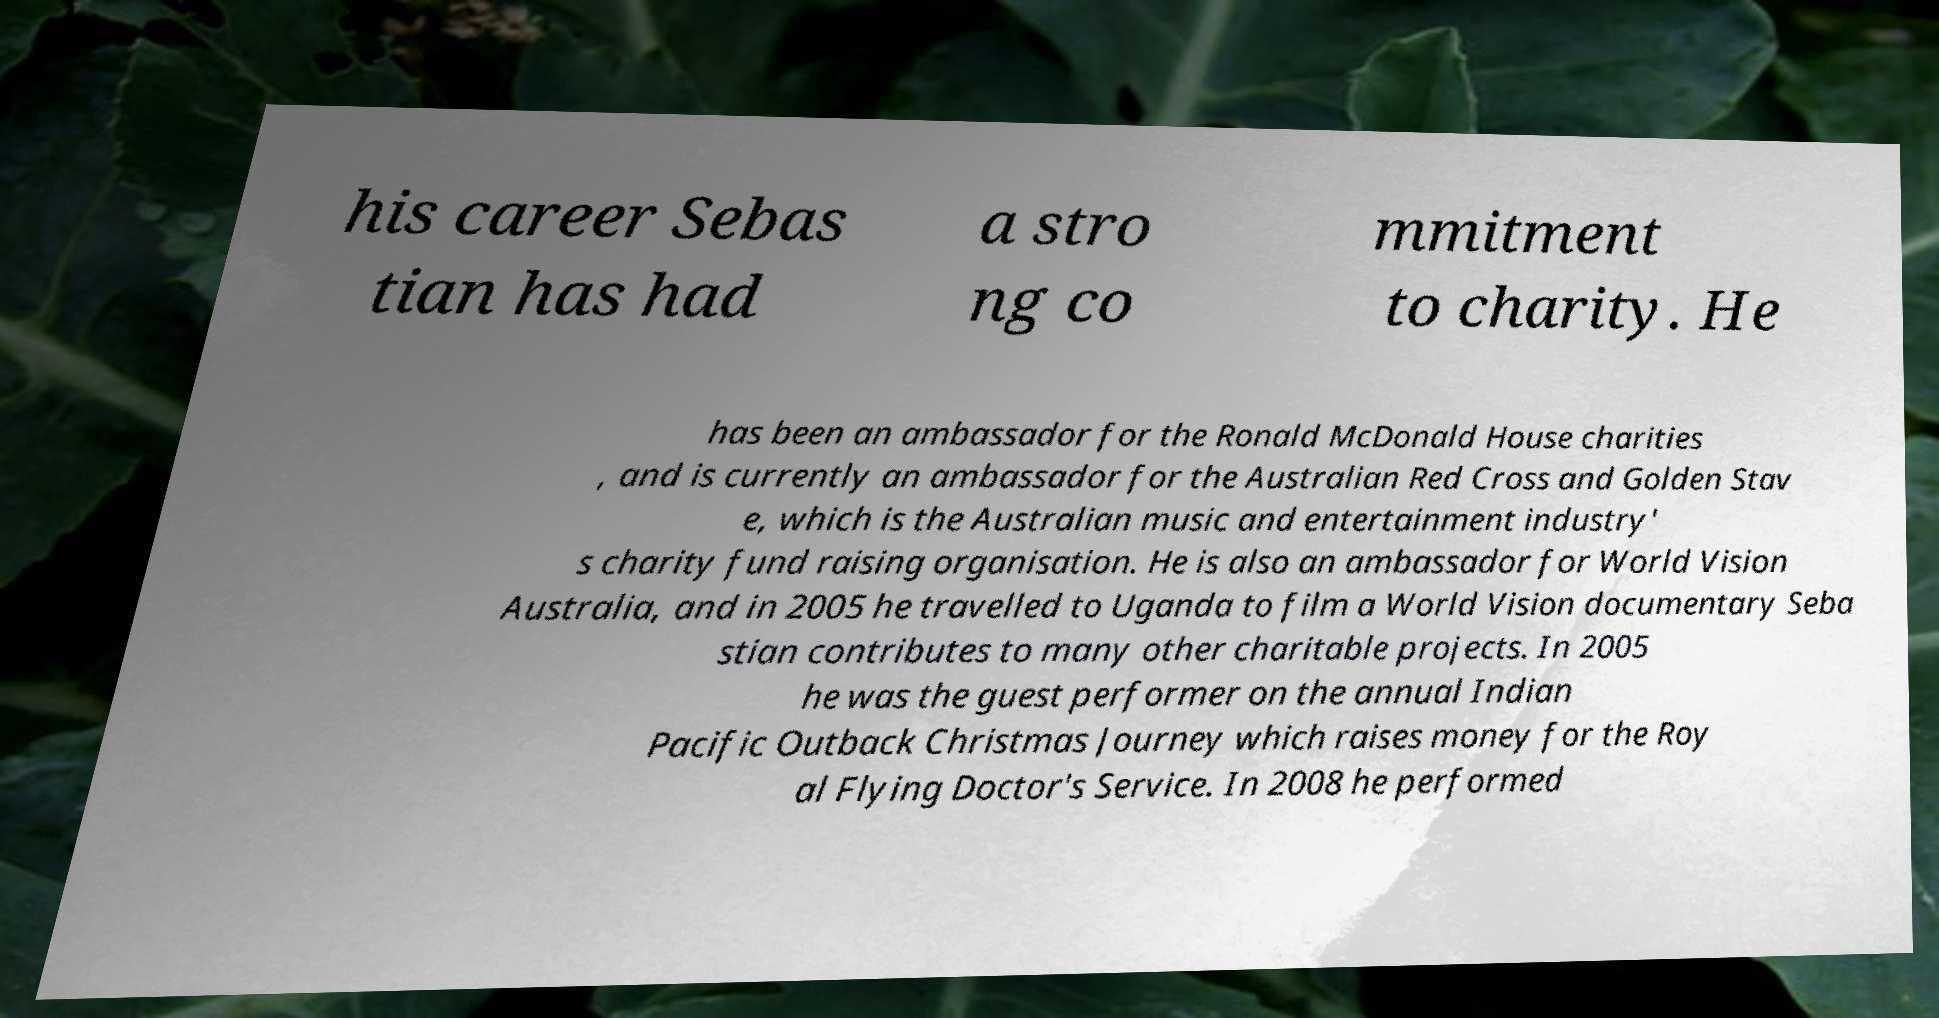I need the written content from this picture converted into text. Can you do that? his career Sebas tian has had a stro ng co mmitment to charity. He has been an ambassador for the Ronald McDonald House charities , and is currently an ambassador for the Australian Red Cross and Golden Stav e, which is the Australian music and entertainment industry' s charity fund raising organisation. He is also an ambassador for World Vision Australia, and in 2005 he travelled to Uganda to film a World Vision documentary Seba stian contributes to many other charitable projects. In 2005 he was the guest performer on the annual Indian Pacific Outback Christmas Journey which raises money for the Roy al Flying Doctor's Service. In 2008 he performed 